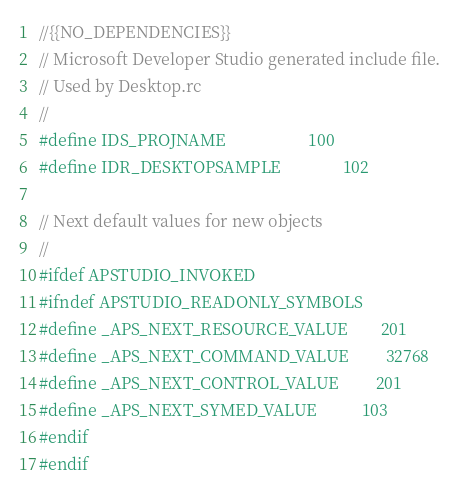Convert code to text. <code><loc_0><loc_0><loc_500><loc_500><_C_>//{{NO_DEPENDENCIES}}
// Microsoft Developer Studio generated include file.
// Used by Desktop.rc
//
#define IDS_PROJNAME                    100
#define IDR_DESKTOPSAMPLE               102

// Next default values for new objects
// 
#ifdef APSTUDIO_INVOKED
#ifndef APSTUDIO_READONLY_SYMBOLS
#define _APS_NEXT_RESOURCE_VALUE        201
#define _APS_NEXT_COMMAND_VALUE         32768
#define _APS_NEXT_CONTROL_VALUE         201
#define _APS_NEXT_SYMED_VALUE           103
#endif
#endif
</code> 